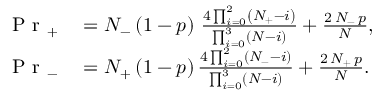<formula> <loc_0><loc_0><loc_500><loc_500>\begin{array} { r l } { P r _ { + } } & = N _ { - } \left ( 1 - p \right ) \, \frac { 4 \prod _ { i = 0 } ^ { 2 } \left ( N _ { + } - i \right ) } { \prod _ { i = 0 } ^ { 3 } \left ( N - i \right ) } + \frac { 2 \, N _ { - } \, p } { N } , } \\ { P r _ { - } } & = N _ { + } \left ( 1 - p \right ) \frac { 4 \prod _ { i = 0 } ^ { 2 } \left ( N _ { - } - i \right ) } { \prod _ { i = 0 } ^ { 3 } \left ( N - i \right ) } + \frac { 2 \, N _ { + } \, p } { N } . } \end{array}</formula> 